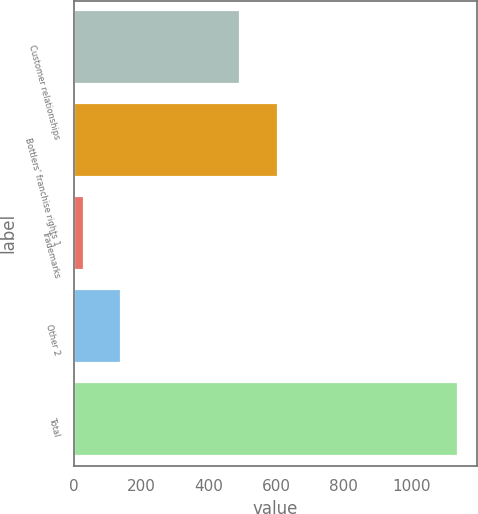Convert chart. <chart><loc_0><loc_0><loc_500><loc_500><bar_chart><fcel>Customer relationships<fcel>Bottlers' franchise rights 1<fcel>Trademarks<fcel>Other 2<fcel>Total<nl><fcel>493<fcel>603.8<fcel>29<fcel>139.8<fcel>1137<nl></chart> 